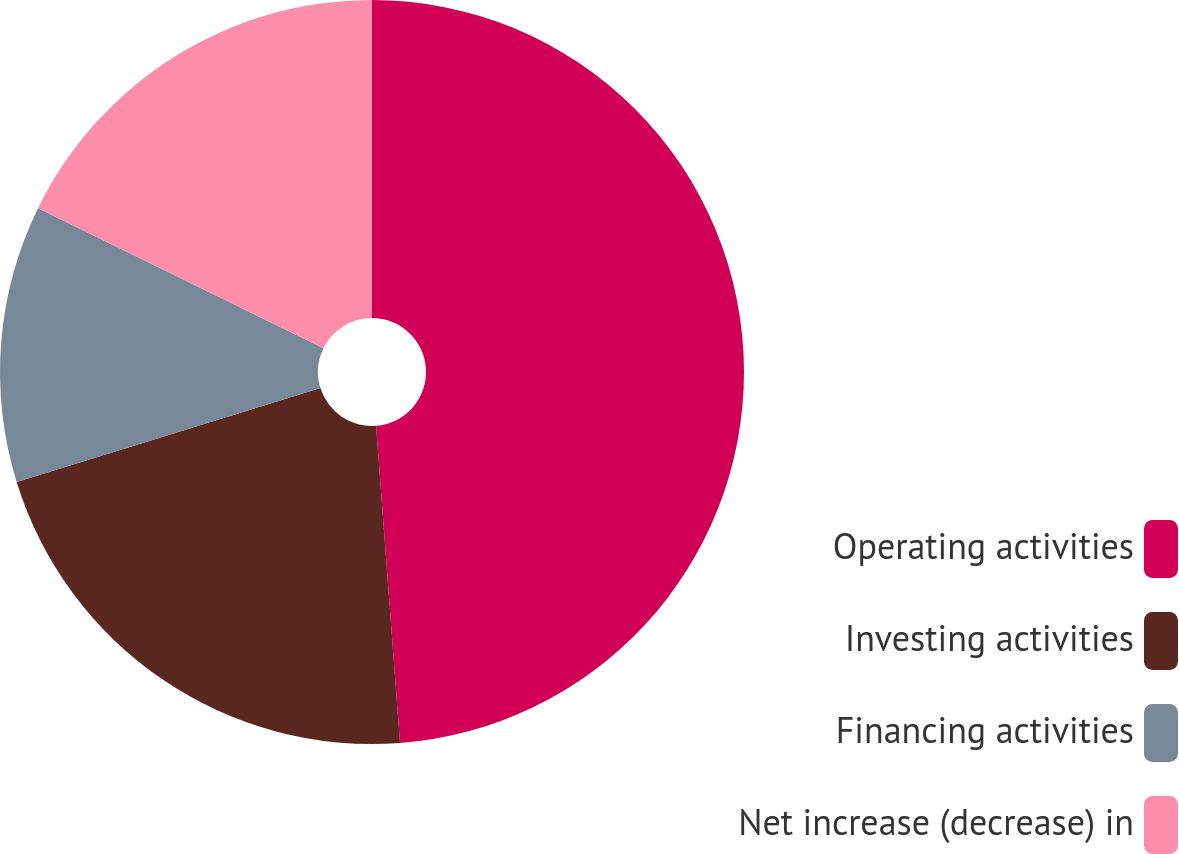<chart> <loc_0><loc_0><loc_500><loc_500><pie_chart><fcel>Operating activities<fcel>Investing activities<fcel>Financing activities<fcel>Net increase (decrease) in<nl><fcel>48.8%<fcel>21.42%<fcel>12.04%<fcel>17.74%<nl></chart> 